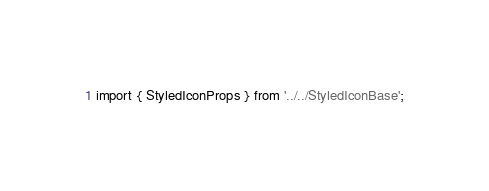<code> <loc_0><loc_0><loc_500><loc_500><_TypeScript_>import { StyledIconProps } from '../../StyledIconBase';</code> 